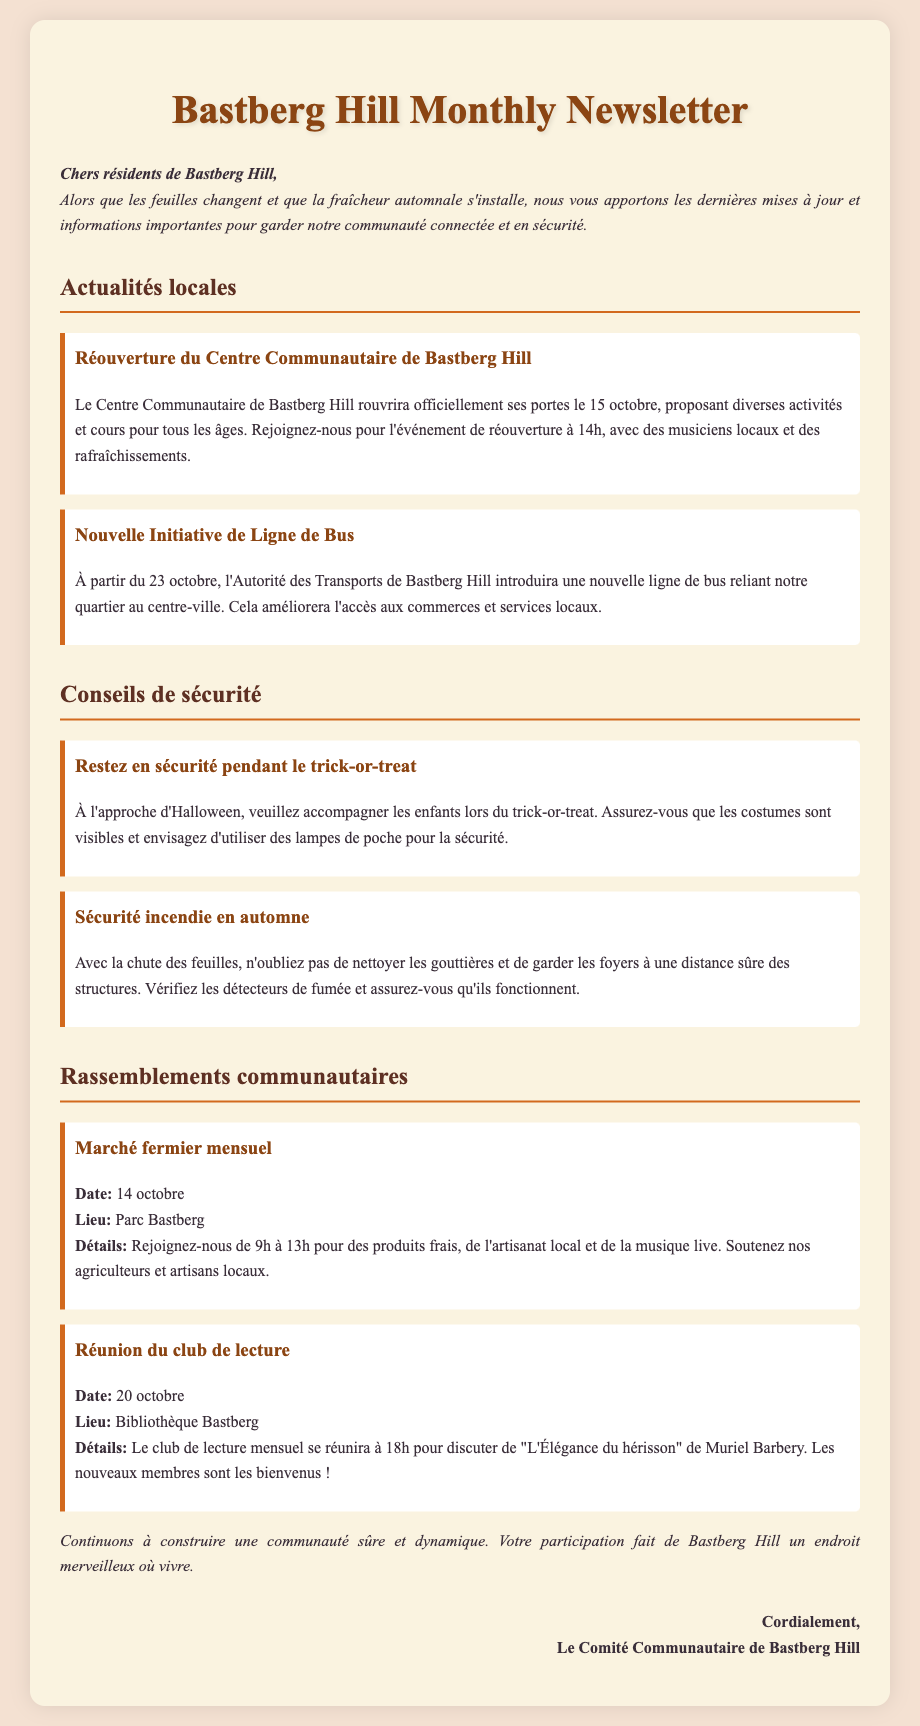Quel est le titre de la lettre d'information ? Le titre de la lettre d'information est spécifié en haut du document et indique le sujet principal.
Answer: Bastberg Hill Monthly Newsletter Quelle est la date de la réouverture du Centre Communautaire ? La date de réouverture est mentionnée dans la section des actualités locales, précisant quand l'événement aura lieu.
Answer: 15 octobre Que doit-on faire pour la sécurité lors du trick-or-treat ? Cette information figure dans les conseils de sécurité et donne une directive sur la sécurité pendant Halloween.
Answer: Accompagner les enfants Quelle est la date du marché fermier mensuel ? La date de l'événement est fournie dans la section des rassemblements communautaires.
Answer: 14 octobre Quel livre sera discuté lors de la réunion du club de lecture ? Le livre est mentionné dans les détails de l'événement de la réunion du club de lecture.
Answer: L'Élégance du hérisson Combien de temps durera le marché fermier ? La durée de l'événement est précisée dans la section des rassemblements communautaires, indiquant ses heures.
Answer: 9h à 13h Quand sera lancée la nouvelle ligne de bus ? La date d'introduction de la nouvelle ligne de bus est mentionnée dans la section des actualités locales.
Answer: 23 octobre Pourquoi est-il important de vérifier les détecteurs de fumée ? Cette information est donnée dans les conseils de sécurité, soulignant l'importance de la prévention des incendies.
Answer: Sécurité incendie Quel type d'activités sera proposé au Centre Communautaire ? Les activités disponibles sont décrites dans l'annonce de réouverture du Centre Communautaire.
Answer: Diverses activités et cours 